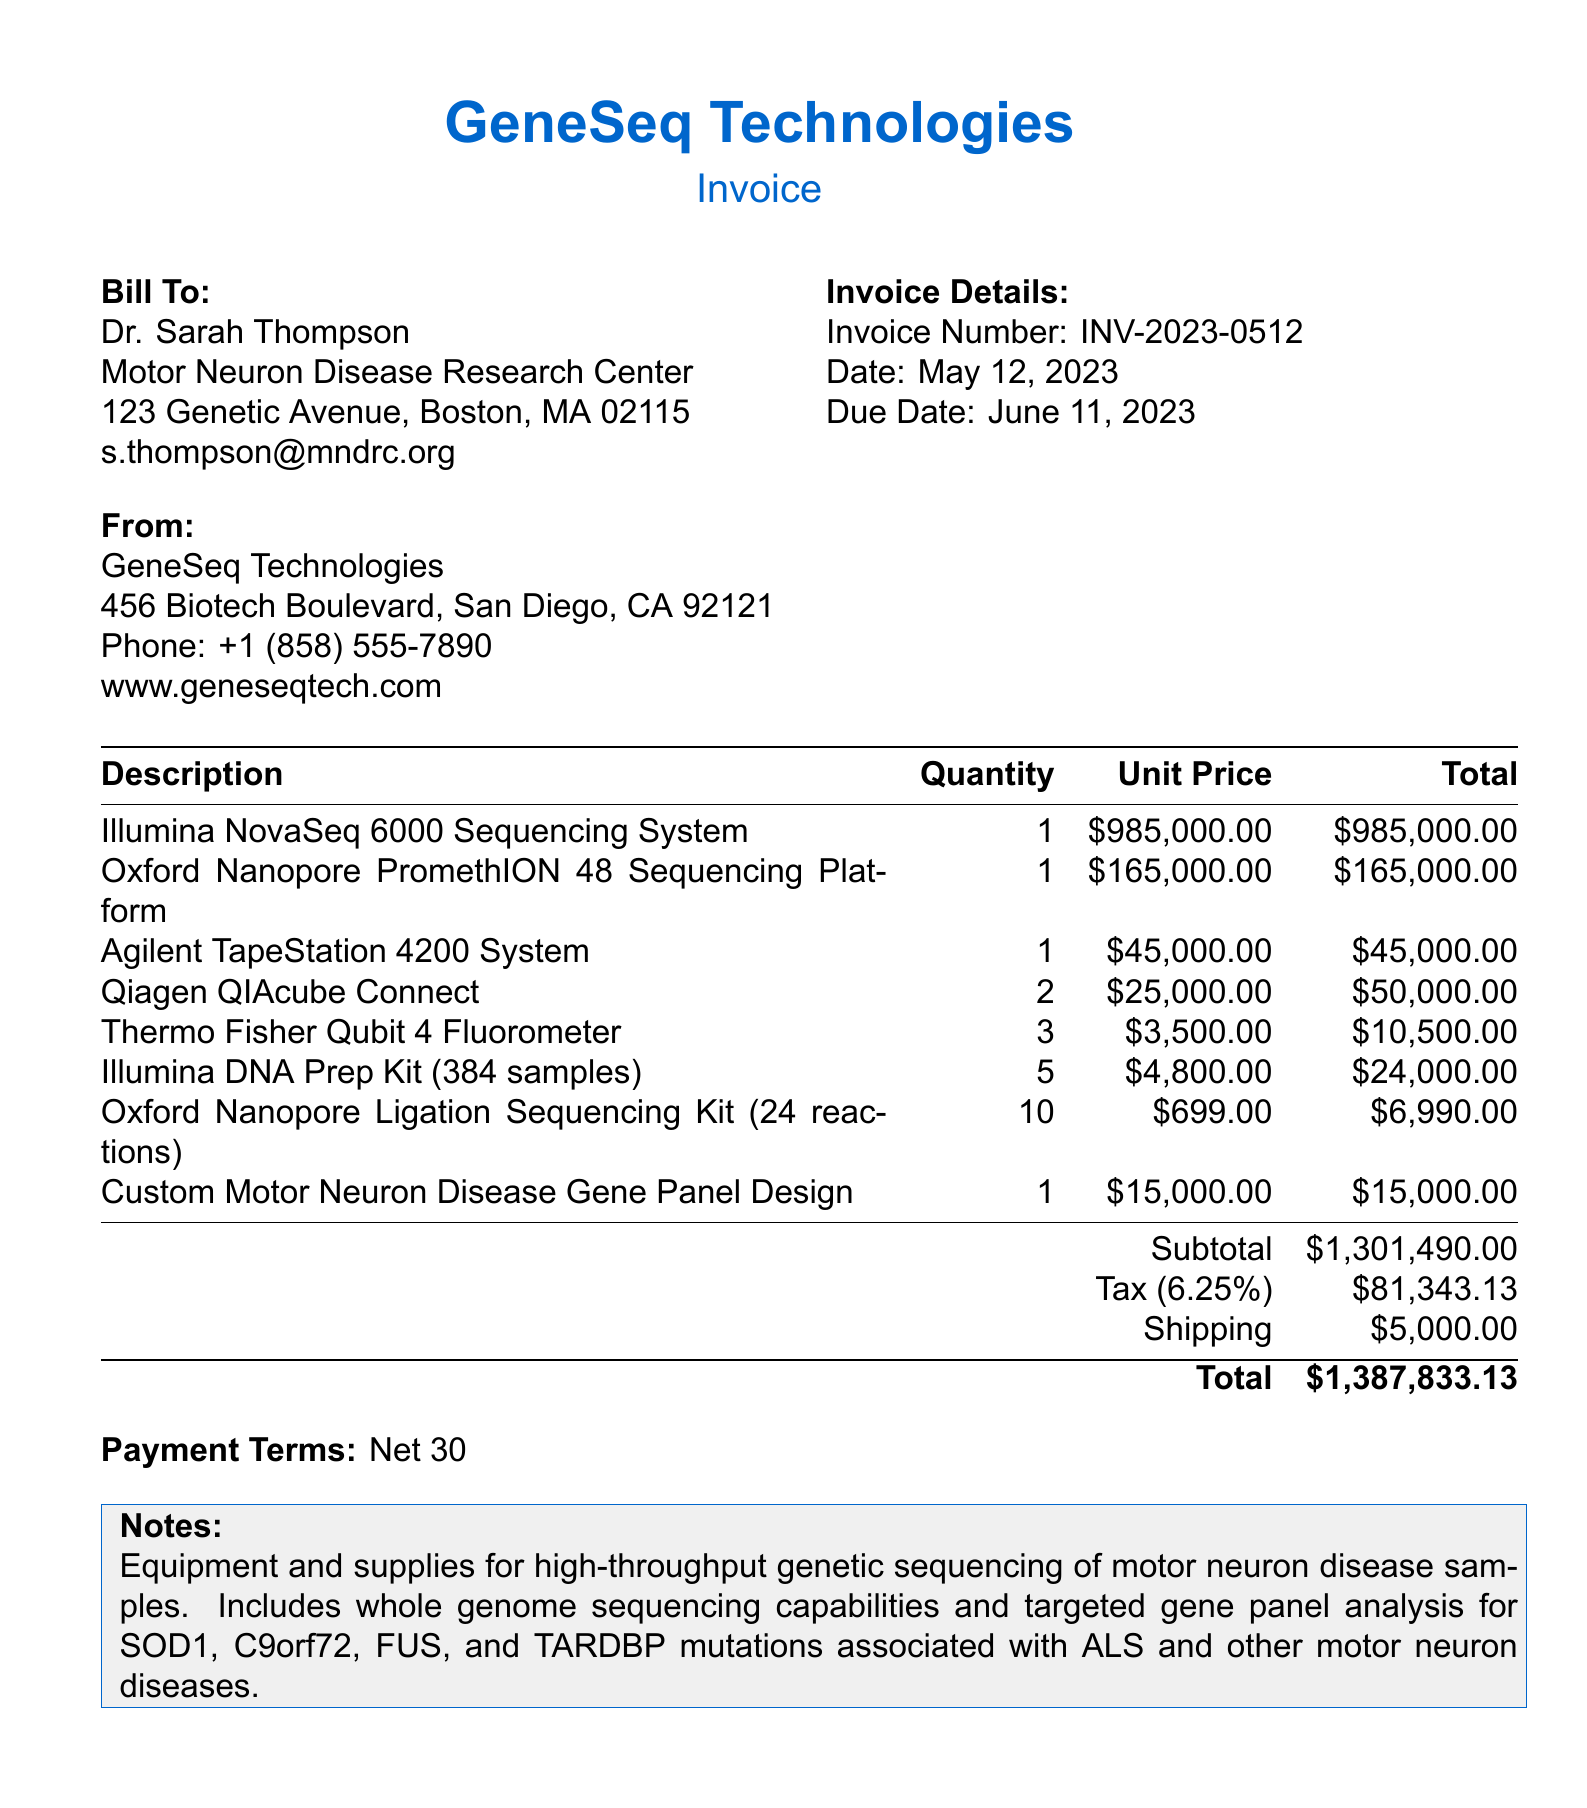what is the invoice number? The invoice number is specifically listed in the document for identification, which is INV-2023-0512.
Answer: INV-2023-0512 who is the bill to? The bill to section names the individual and institution responsible for the payment, which is Dr. Sarah Thompson at the Motor Neuron Disease Research Center.
Answer: Dr. Sarah Thompson what is the total amount of the invoice? The total amount is calculated at the bottom of the invoice after adding the subtotal, tax, and shipping, which comes to 1,387,833.13.
Answer: 1,387,833.13 how many items are included in the invoice? There are multiple specific items listed in the invoice under the itemized list, which account for 8 unique entries.
Answer: 8 what is the due date of the invoice? The due date is provided in the document, indicating when payment is expected, which is June 11, 2023.
Answer: June 11, 2023 what is the subtotal amount before tax? The subtotal represents the total cost of items prior to tax and shipping, which is stated as 1,301,490.00.
Answer: 1,301,490.00 what is the shipping cost? The document specifies that the charge for shipping is additional to the subtotal and tax, which is 5,000.00.
Answer: 5,000.00 what is the purpose of the invoice as mentioned in the notes? The notes provide a summary of the invoice's aim related to genetic sequencing for motor neuron disease research, emphasizing high-throughput capabilities.
Answer: Equipment and supplies for high-throughput genetic sequencing of motor neuron disease samples 